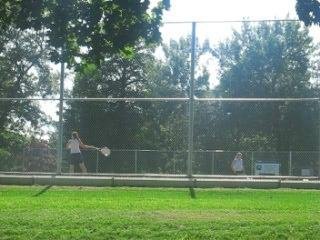What would this fence help to contain? balls 